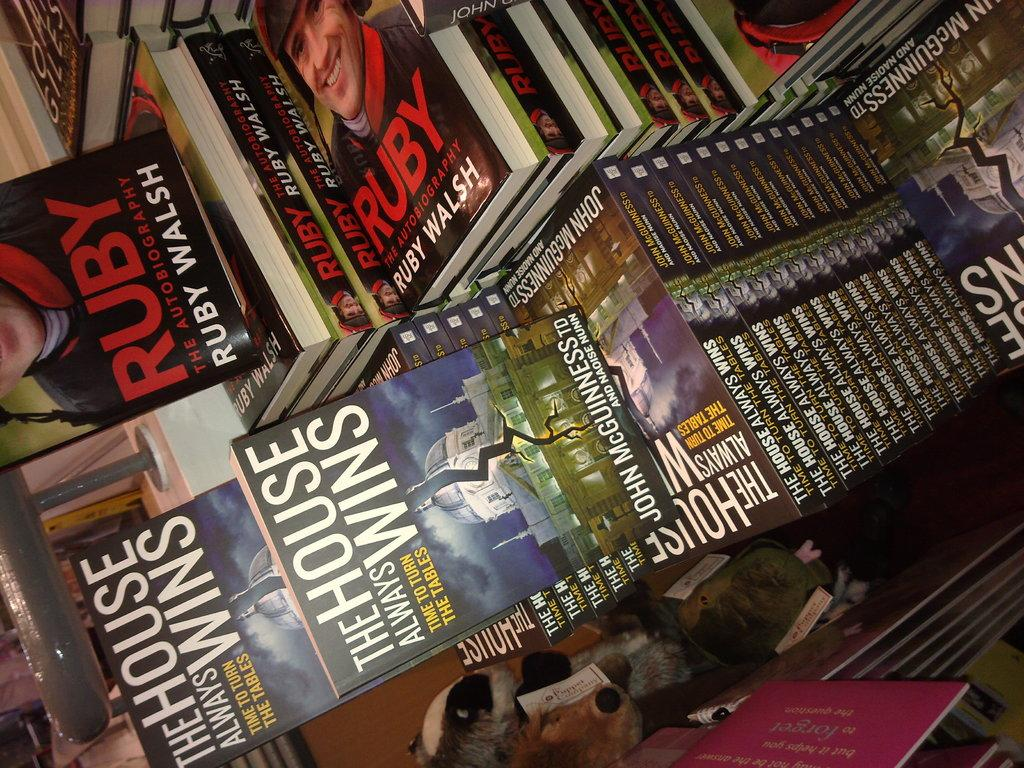<image>
Relay a brief, clear account of the picture shown. The book titled The House Always Wins is displayed next to another stack of books. 